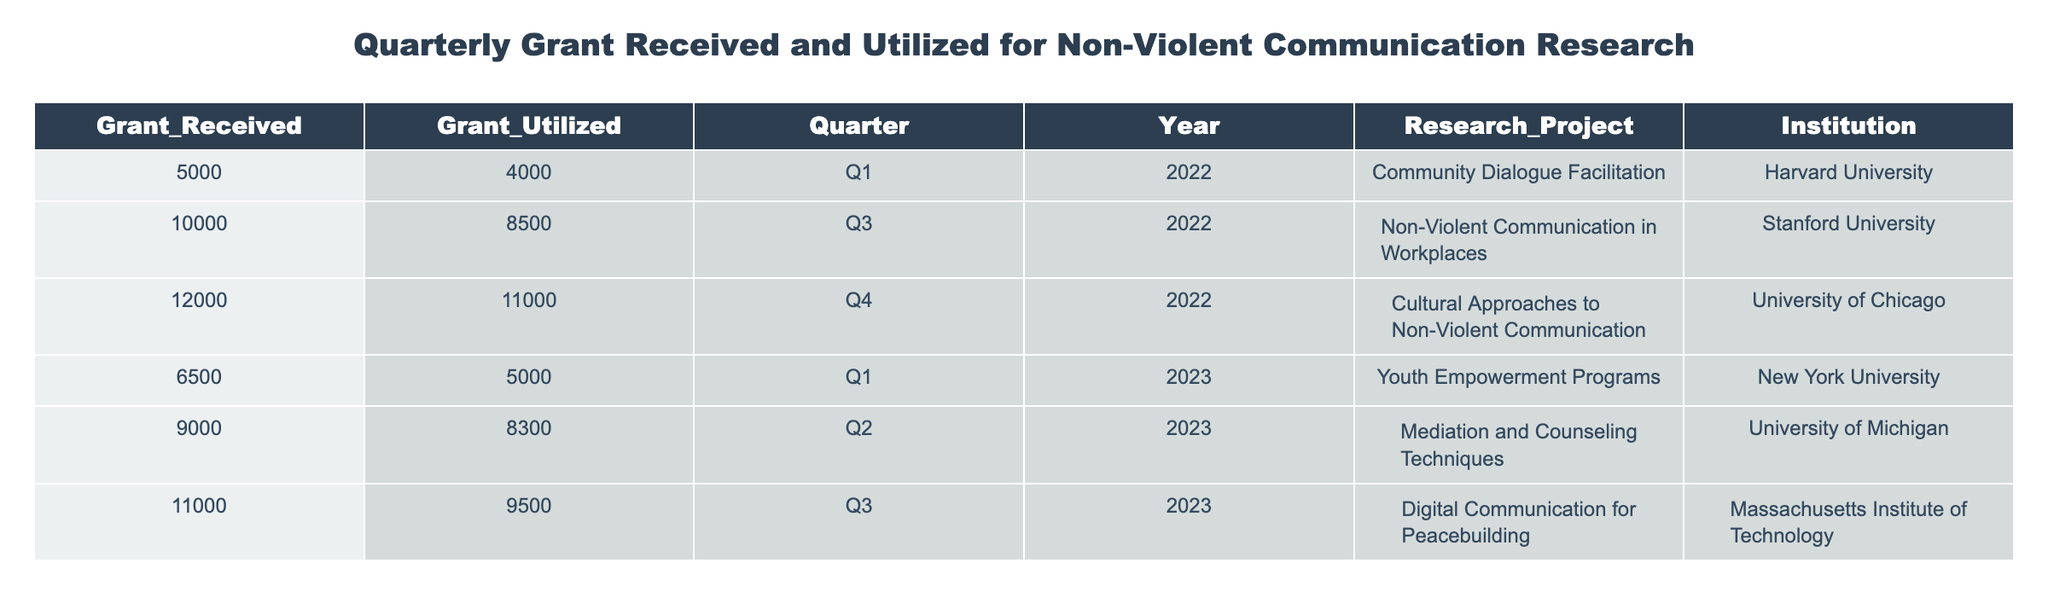What is the total amount of grants received in Q1 2022? From the table, we look for the row where the Quarter is Q1 and the Year is 2022. The table indicates that in Q1 2022, the Grant Received is 5000.
Answer: 5000 How much grant was utilized for the project "Non-Violent Communication in Workplaces"? We identify the row corresponding to the project "Non-Violent Communication in Workplaces." According to the table, the Grant Utilized for this project is 8500.
Answer: 8500 What was the difference between grant received and utilized in Q4 2022? For Q4 2022, the Grant Received is 12000 and the Grant Utilized is 11000. The difference can be calculated as 12000 - 11000 = 1000.
Answer: 1000 What is the average grant received across all the quarters listed? We first add the Grant Received amounts: 5000 + 10000 + 12000 + 6500 + 9000 + 11000 = 50500. There are 6 entries, so the average is 50500 / 6 = 8416.67.
Answer: 8416.67 Did the grant utilized in Q1 2023 exceed the amount received? For Q1 2023, the Grant Received is 6500 and the Grant Utilized is 5000. Since 5000 is less than 6500, the statement is false.
Answer: No Which research project had the highest total grant utilized? We compare the Grant Utilized for all projects: 4000, 8500, 11000, 5000, 8300, and 9500. The highest amount is 11000 for "Cultural Approaches to Non-Violent Communication."
Answer: Cultural Approaches to Non-Violent Communication What percentage of the total grants received was utilized in Q2 2023? In Q2 2023, the Grant Received is 9000 and the Grant Utilized is 8300. To find the percentage utilized, we calculate (8300 / 9000) * 100 = 92.22%.
Answer: 92.22% What is the total amount of grants utilized throughout 2023? We sum the Grant Utilized amounts for 2023: 5000 (Q1) + 8300 (Q2) + 9500 (Q3) = 22800.
Answer: 22800 Was the total grant received in 2022 higher than in 2023? In 2022, the total grants received are: 5000 (Q1) + 10000 (Q3) + 12000 (Q4) = 27000. For 2023, the totals are: 6500 (Q1) + 9000 (Q2) + 11000 (Q3) = 27000. Since both totals are equal, the statement is false.
Answer: No 